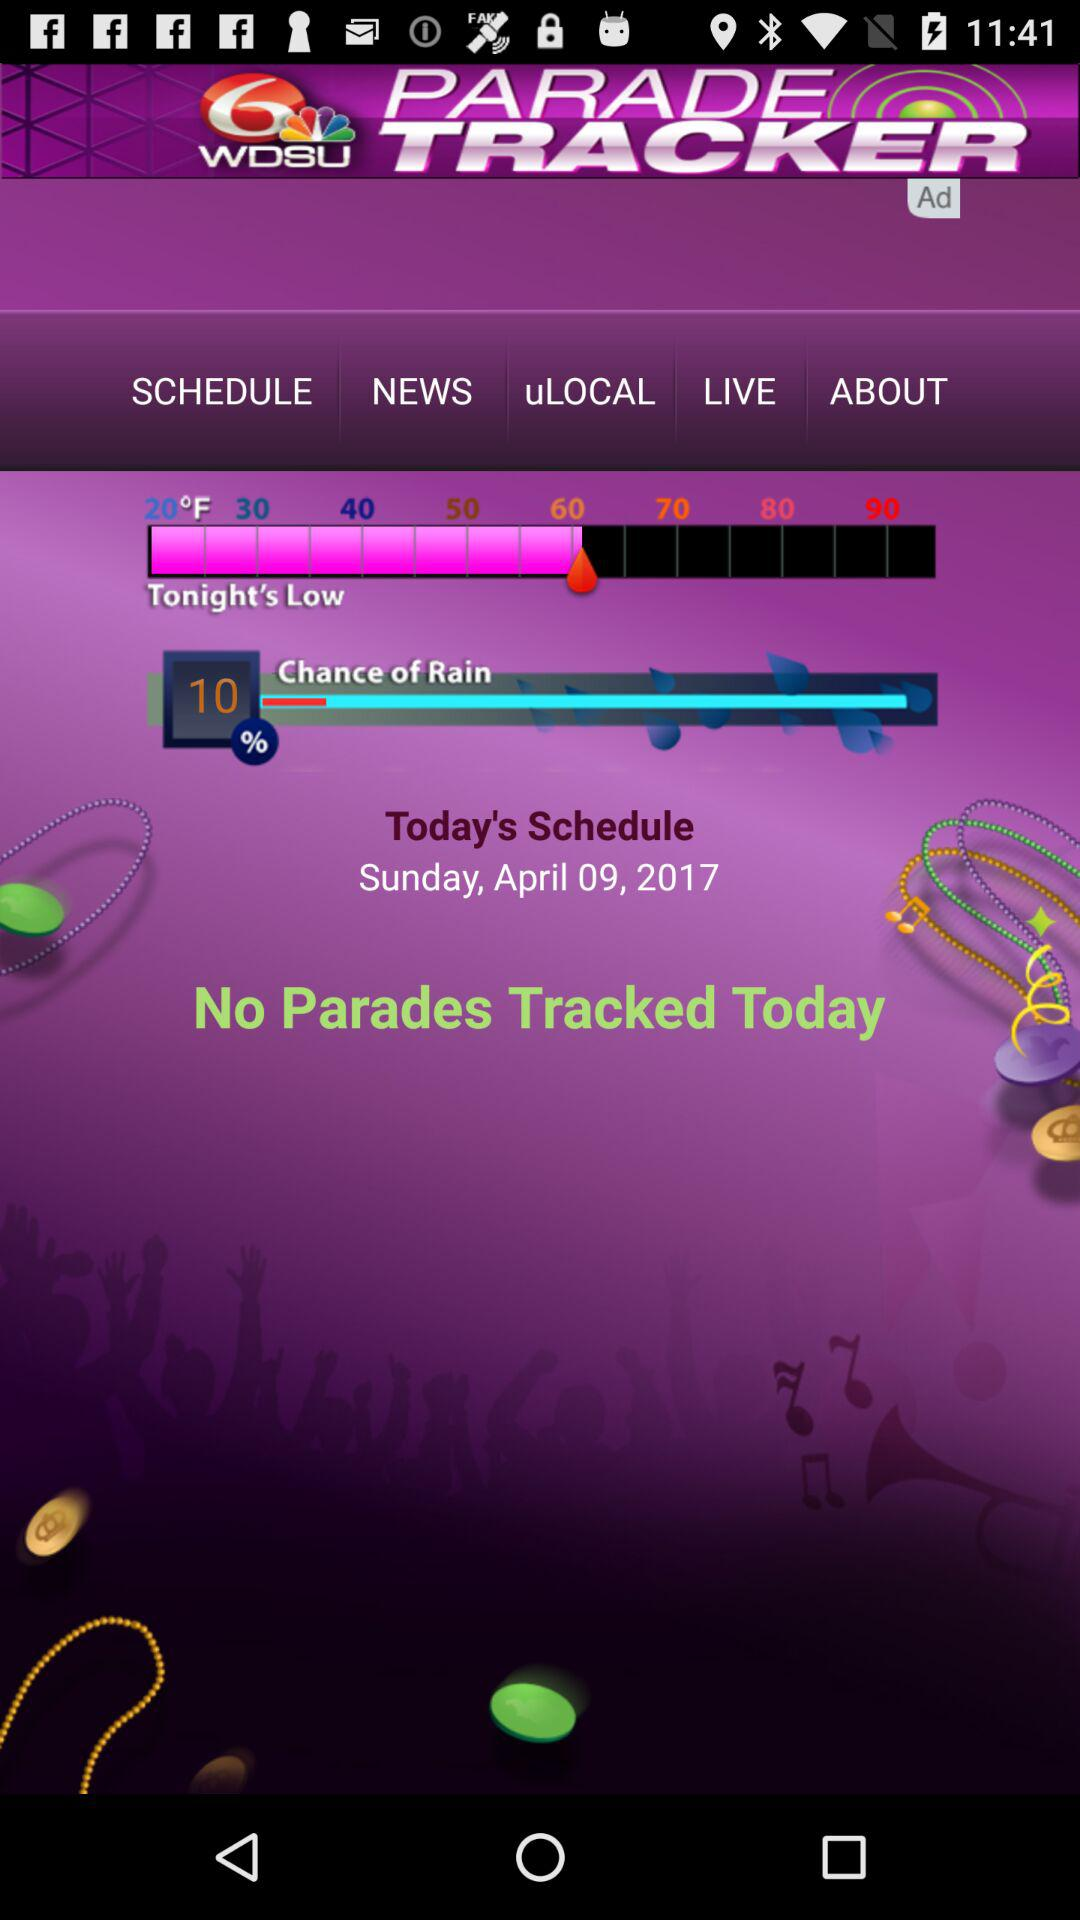What is the day on the scheduled date? The day on the scheduled date is Sunday. 